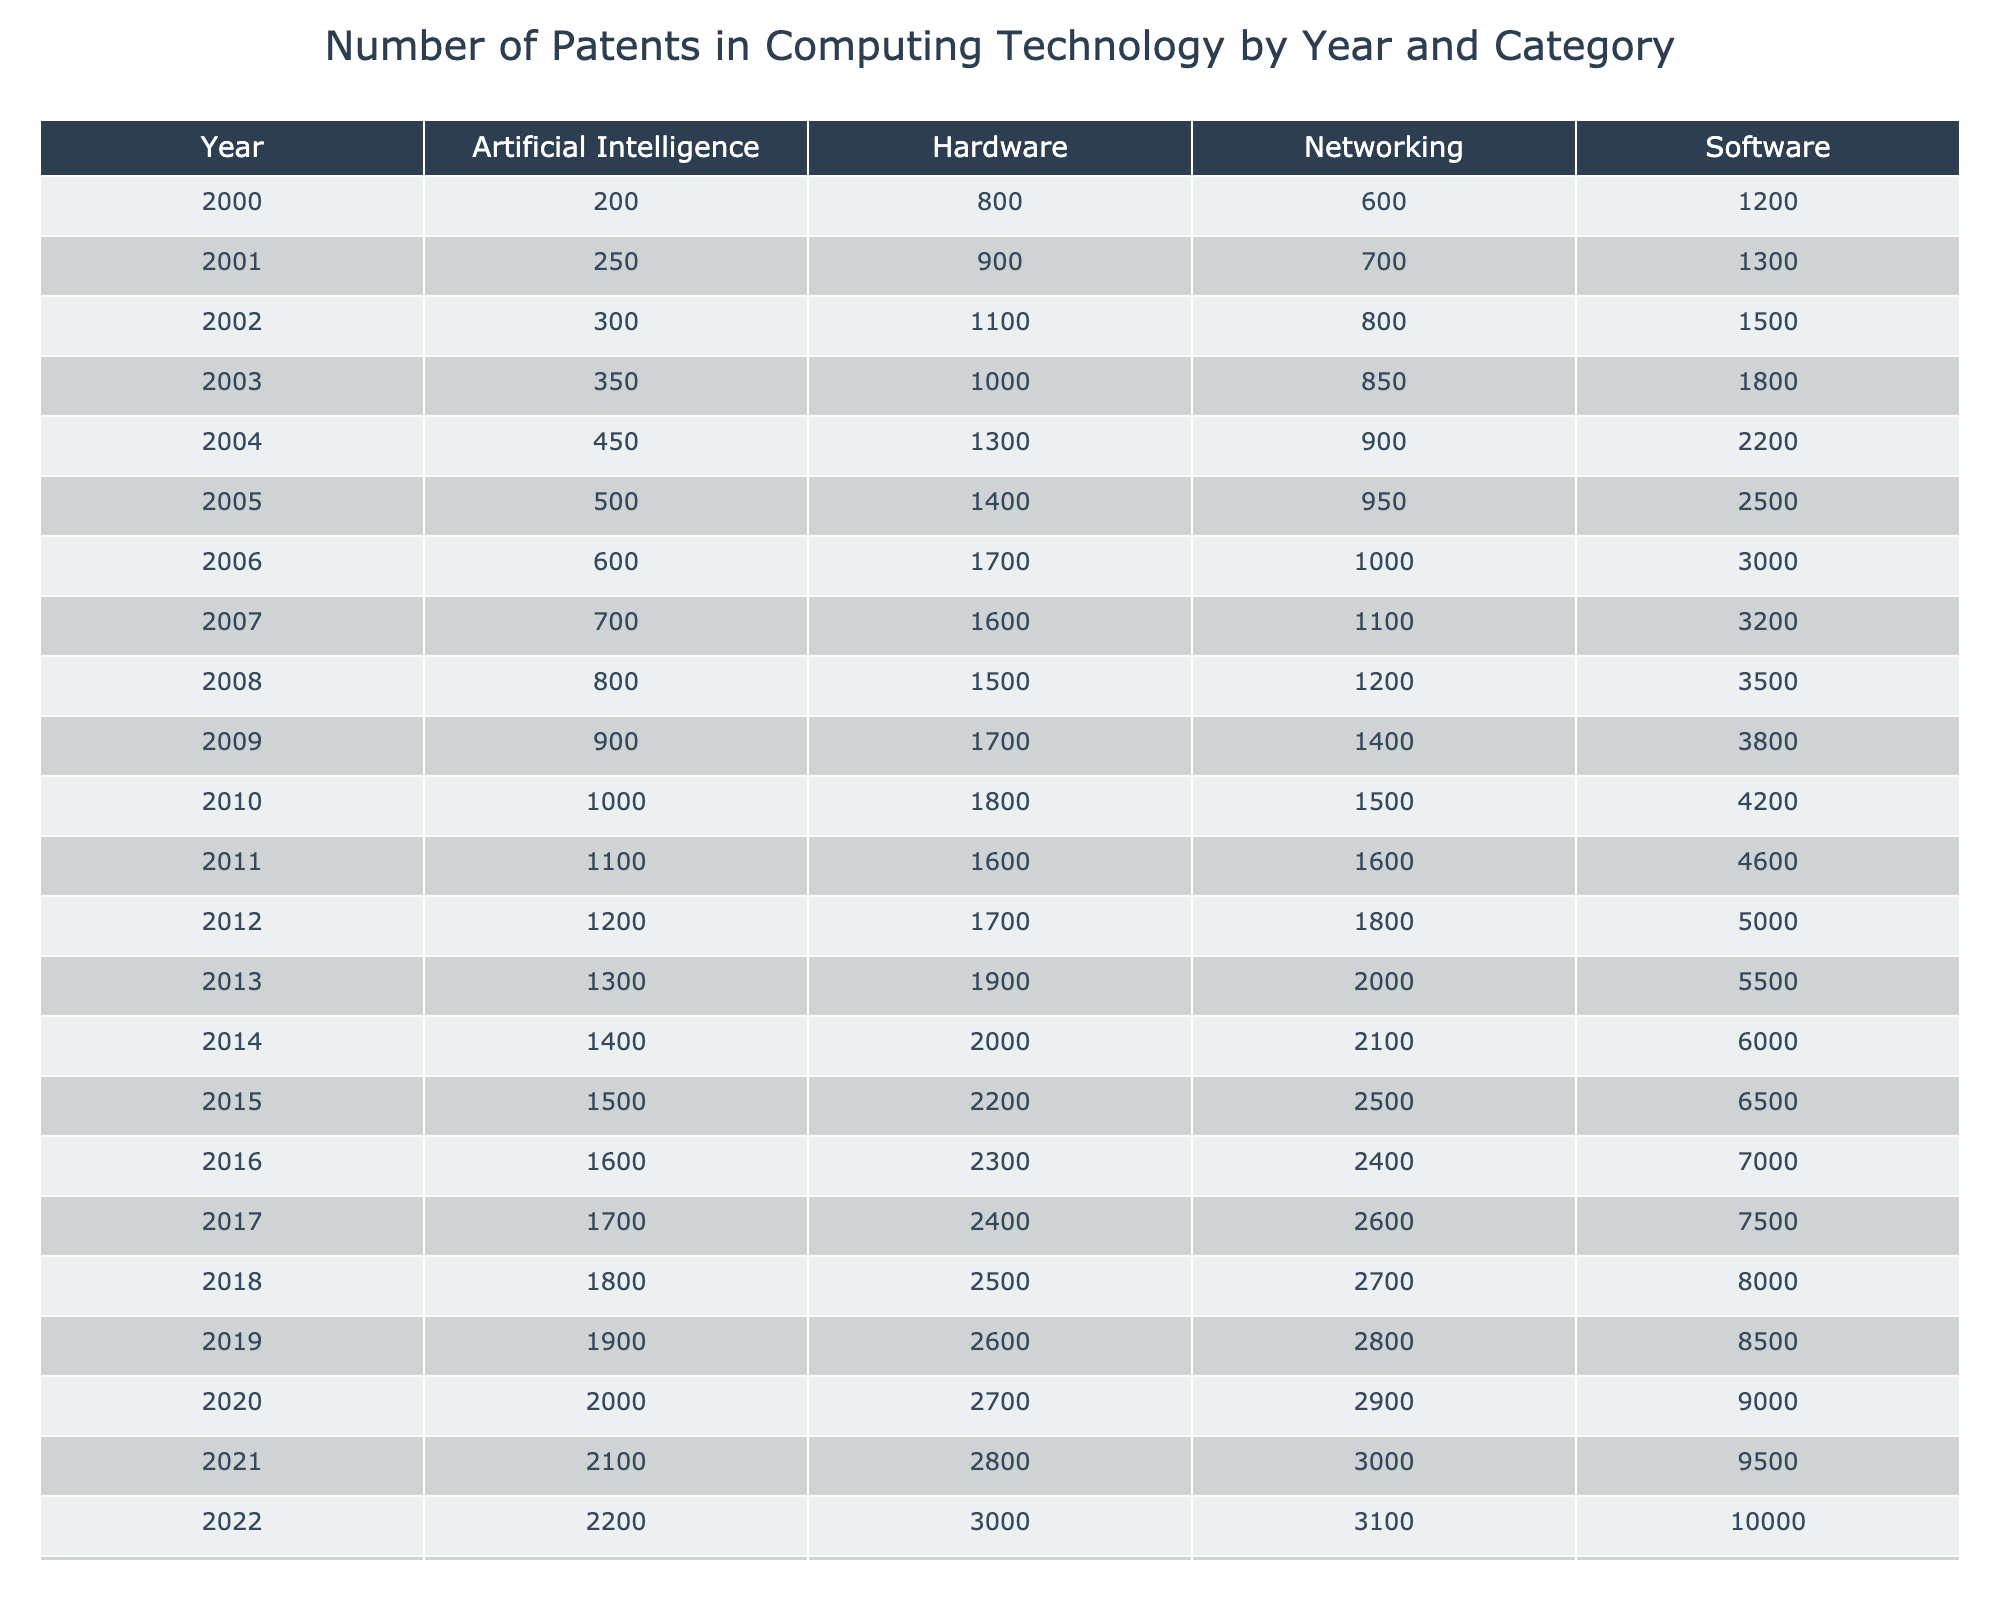What category had the highest patent count in 2020? Looking at the data for the year 2020, the Software category had a patent count of 9000, which is higher than the counts for Hardware (2700), Networking (2900), and Artificial Intelligence (2000).
Answer: Software In which year did the number of patents in Networking exceed 2000 for the first time? By examining the Networking values year by year, we see that it first exceeded 2000 patents in the year 2013 when the count was 2000, based on the records from previous years.
Answer: 2013 What is the total number of patents for Artificial Intelligence from 2000 to 2023? To find the total patents for Artificial Intelligence, I sum the counts: (200 + 250 + 300 + 350 + 450 + 500 + 600 + 700 + 800 + 900 + 1000 + 1100 + 1200 + 1300 + 1400 + 1500 + 1600 + 1700 + 1800 + 1900 + 2000 + 2100 + 2200 + 2300) = 22650.
Answer: 22650 Which category experienced the largest increase in patent count from 2010 to 2015? For 2010, Software had a count of 4200, and in 2015 it increased to 6500, indicating a rise of 2300. Hardware grew from 1800 to 2200, an increase of 400. Networking rose from 1500 to 2500 (1000 increase), and Artificial Intelligence from 1000 to 1500 (500 increase). Thus, the largest increase was in Software.
Answer: Software Did the total number of patents in Software in 2022 show growth compared to 2021? The counts for Software in 2021 and 2022 are 9500 and 10000 respectively. Since 10000 is greater than 9500, it shows that there was indeed growth in the number of patents.
Answer: Yes What was the average number of patents awarded annually in the category of Hardware between 2000 and 2023? The total patent count for Hardware over the years is 800 + 900 + 1100 + 1300 + 1400 + 1700 + 1600 + 1500 + 1700 + 1800 + 1600 + 1700 + 1900 + 2000 + 2200 + 2300 + 2400 + 2500 + 2600 + 2700 + 2800 + 3000 + 3100 = 49300. There are 24 data points, so the average is 49300 / 24 = approximately 2054.17.
Answer: 2054.17 What was the difference in patent counts between Software and Networking in 2023? In 2023, the count for Software was 11000 while Networking was 3200. The difference is 11000 - 3200 = 7800.
Answer: 7800 In which category did the patent counts show consistent increases from 2000 to 2023? Looking at the trends from 2000 to 2023, Software shows consistent growth every year, from 1200 patents in 2000 to 11000 in 2023. Other categories had fluctuations, meaning only Software had consistent increases.
Answer: Software What was the highest patent count in the Hardware category, and in what year did it occur? The highest count for Hardware is 3100 in the year 2023, which is greater than any other annual counts recorded in previous years.
Answer: 3100 in 2023 Was the patent count for Artificial Intelligence in 2018 less than the count for Hardware in the same year? In 2018, the count for Artificial Intelligence was 1800, whereas Hardware had a patent count of 2500. Since 1800 is less than 2500, the answer is yes.
Answer: Yes 